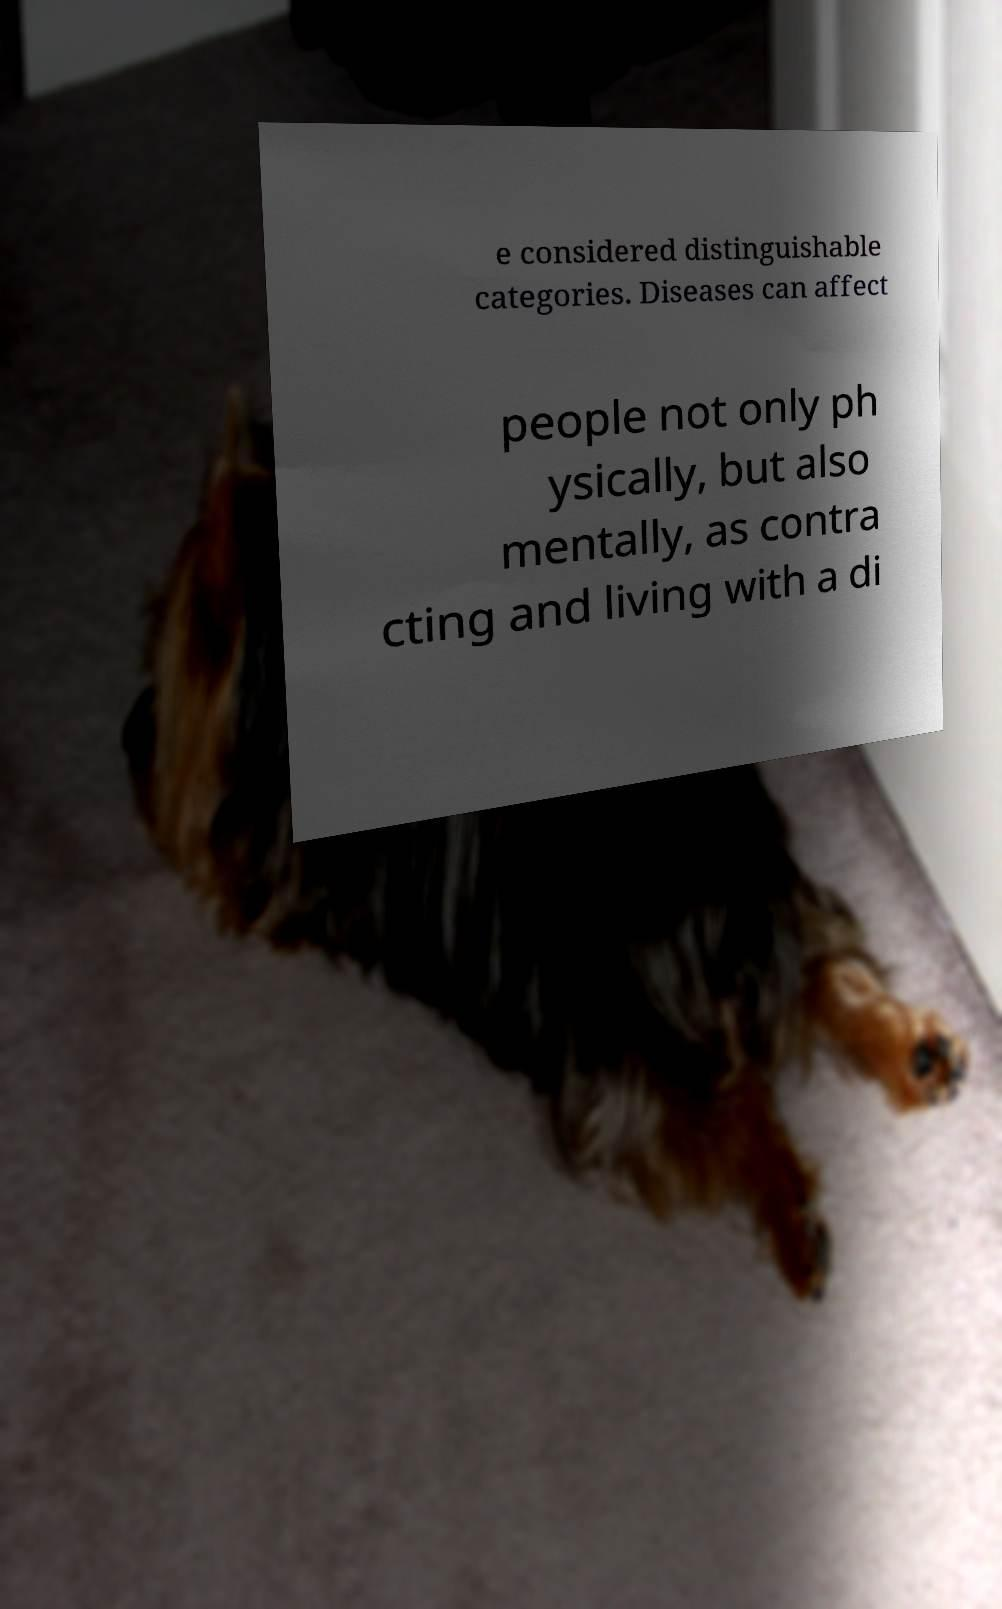Please identify and transcribe the text found in this image. e considered distinguishable categories. Diseases can affect people not only ph ysically, but also mentally, as contra cting and living with a di 